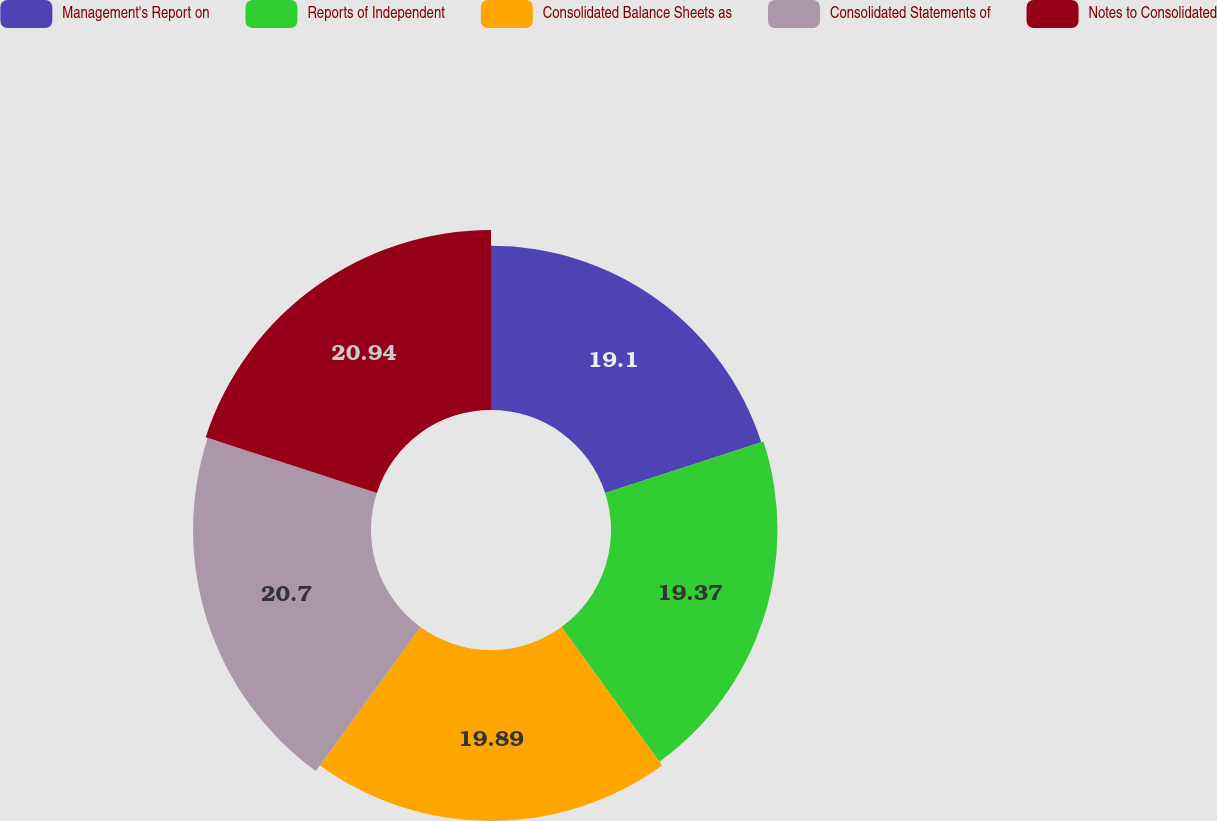Convert chart to OTSL. <chart><loc_0><loc_0><loc_500><loc_500><pie_chart><fcel>Management's Report on<fcel>Reports of Independent<fcel>Consolidated Balance Sheets as<fcel>Consolidated Statements of<fcel>Notes to Consolidated<nl><fcel>19.1%<fcel>19.37%<fcel>19.89%<fcel>20.7%<fcel>20.94%<nl></chart> 